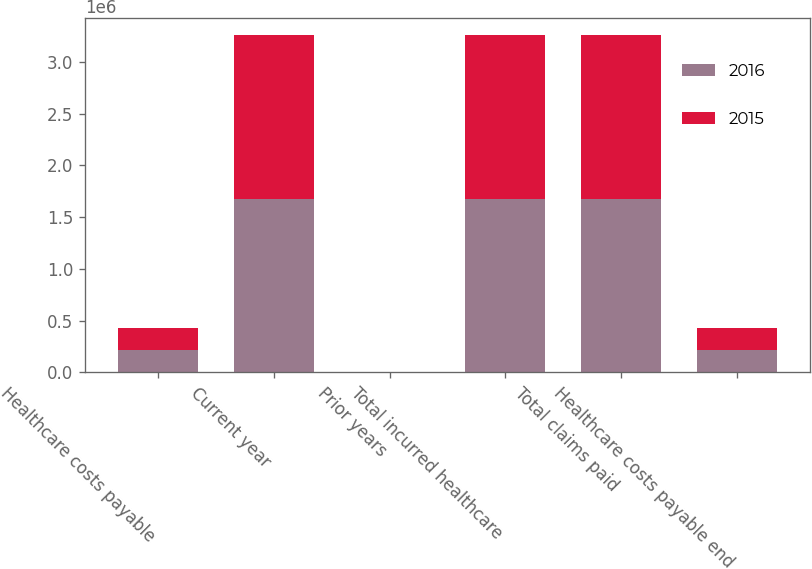Convert chart. <chart><loc_0><loc_0><loc_500><loc_500><stacked_bar_chart><ecel><fcel>Healthcare costs payable<fcel>Current year<fcel>Prior years<fcel>Total incurred healthcare<fcel>Total claims paid<fcel>Healthcare costs payable end<nl><fcel>2016<fcel>212641<fcel>1.67374e+06<fcel>141<fcel>1.6736e+06<fcel>1.67197e+06<fcel>214275<nl><fcel>2015<fcel>214405<fcel>1.58704e+06<fcel>1523<fcel>1.58856e+06<fcel>1.59032e+06<fcel>212641<nl></chart> 